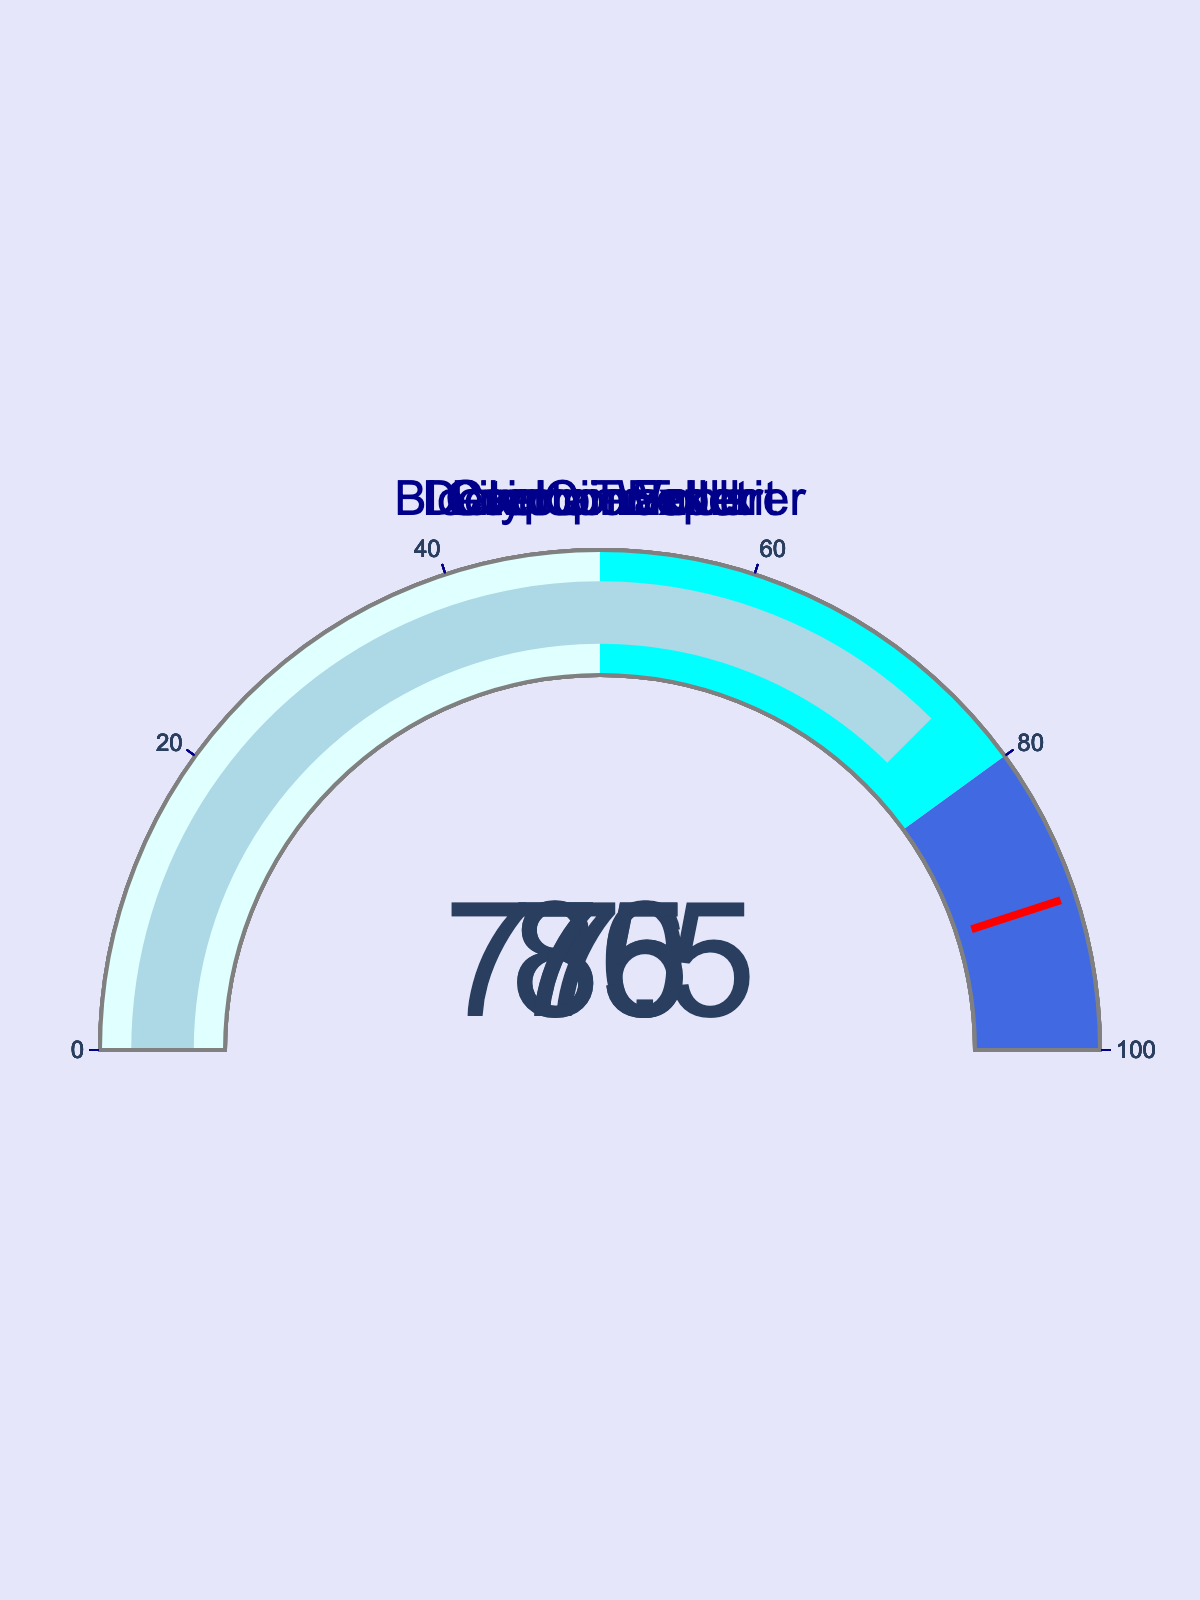What percentage of the target goal has the CryptoTracker app achieved? According to the gauge chart, the CryptoTracker app has reached 85% of its target goal.
Answer: 85% Which app has the lowest percentage of the target goal achieved? By examining the gauge charts, the CoinConverter app has the lowest percentage, which is 70%.
Answer: CoinConverter What is the average percentage of the target goal achieved across all apps? The percentages for all apps are 85, 77.5, 86, 70, and 75. Adding these up gives 393.5. Dividing by the number of apps (5) gives an average of 78.7%.
Answer: 78.7% How many apps have achieved more than 80% of their target goal? By checking the gauge charts, the CryptoTracker and BlockchainExplorer apps have percentages exceeding 80%. Hence, the total number of apps is 2.
Answer: 2 What's the difference in percentage of the target goal achieved between LitecoinWallet and DeveloperToolkit apps? LitecoinWallet has achieved 77.5%, while DeveloperToolkit has achieved 75%. The difference in their percentages is 77.5% - 75% = 2.5%.
Answer: 2.5% Which app achieved the highest percentage of its target goal? Among all the gauge charts, the BlockchainExplorer app achieved the highest percentage, which is 86%.
Answer: BlockchainExplorer If the threshold on the gauge indicates a target of 90%, how many apps are below this threshold? By reviewing the gauge charts, all apps (CryptoTracker, LitecoinWallet, BlockchainExplorer, CoinConverter, and DeveloperToolkit) are below the 90% target threshold. Thus, all 5 apps are below the threshold.
Answer: 5 How does the achievement percentage of LitecoinWallet compare to CoinConverter? The percentage for LitecoinWallet is 77.5% and for CoinConverter is 70%. By comparing these percentages, LitecoinWallet has achieved a higher percentage than CoinConverter.
Answer: LitecoinWallet is higher What is the sum of the percentages achieved by all apps? The percentages for all apps are 85, 77.5, 86, 70, and 75. Adding these values together gives a total percentage of 85 + 77.5 + 86 + 70 + 75 = 393.5%.
Answer: 393.5% What color indicates an app within the 50-80% range of its target goal in the chart? By looking at the gauge chart's color coding, the range from 50% to 80% is indicated by the color cyan.
Answer: cyan 